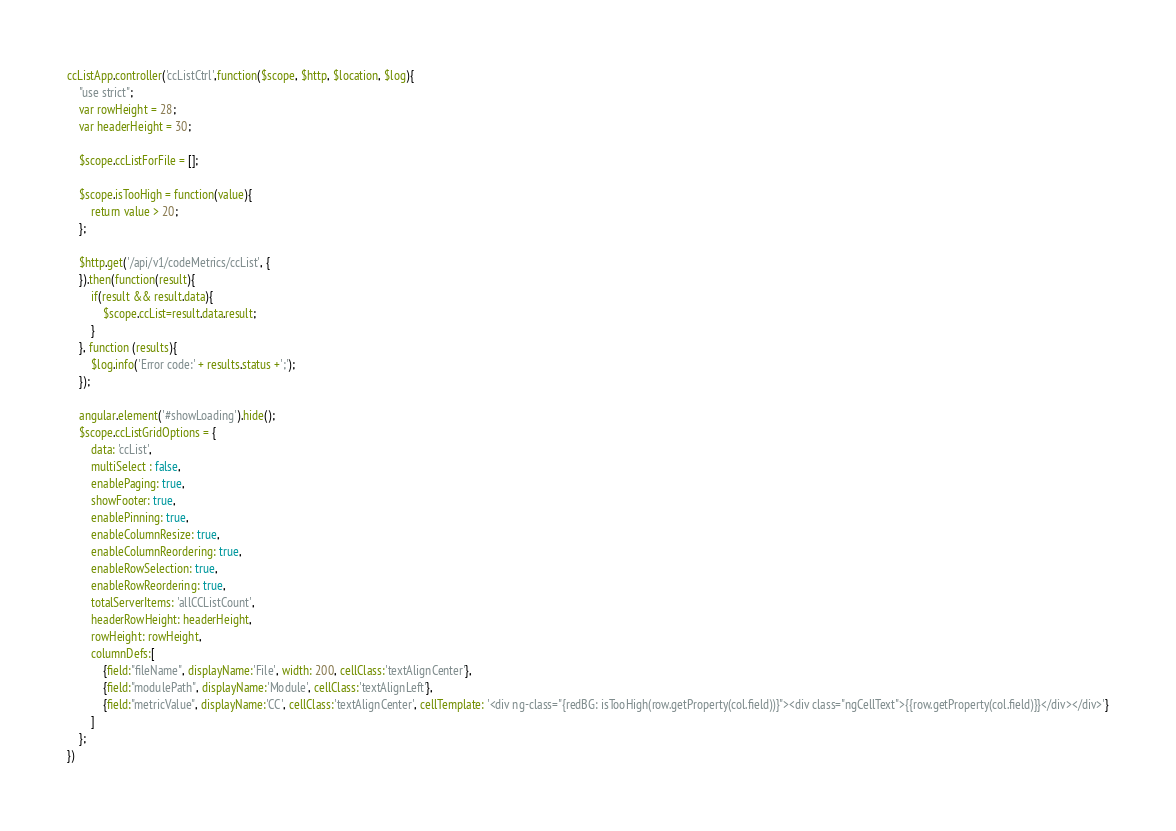Convert code to text. <code><loc_0><loc_0><loc_500><loc_500><_JavaScript_>ccListApp.controller('ccListCtrl',function($scope, $http, $location, $log){
    "use strict";
    var rowHeight = 28;
    var headerHeight = 30;

    $scope.ccListForFile = [];

    $scope.isTooHigh = function(value){
        return value > 20;
    };

    $http.get('/api/v1/codeMetrics/ccList', {
    }).then(function(result){
        if(result && result.data){
            $scope.ccList=result.data.result;
        }
    }, function (results){
        $log.info('Error code:' + results.status +';');
    });

    angular.element('#showLoading').hide();
    $scope.ccListGridOptions = {
        data: 'ccList',
        multiSelect : false,
        enablePaging: true,
        showFooter: true,
        enablePinning: true,
        enableColumnResize: true,
        enableColumnReordering: true,
        enableRowSelection: true,
        enableRowReordering: true,
        totalServerItems: 'allCCListCount',
        headerRowHeight: headerHeight,
        rowHeight: rowHeight,
        columnDefs:[
            {field:"fileName", displayName:'File', width: 200, cellClass:'textAlignCenter'},
            {field:"modulePath", displayName:'Module', cellClass:'textAlignLeft'},
            {field:"metricValue", displayName:'CC', cellClass:'textAlignCenter', cellTemplate: '<div ng-class="{redBG: isTooHigh(row.getProperty(col.field))}"><div class="ngCellText">{{row.getProperty(col.field)}}</div></div>'}
        ]
    };
})</code> 